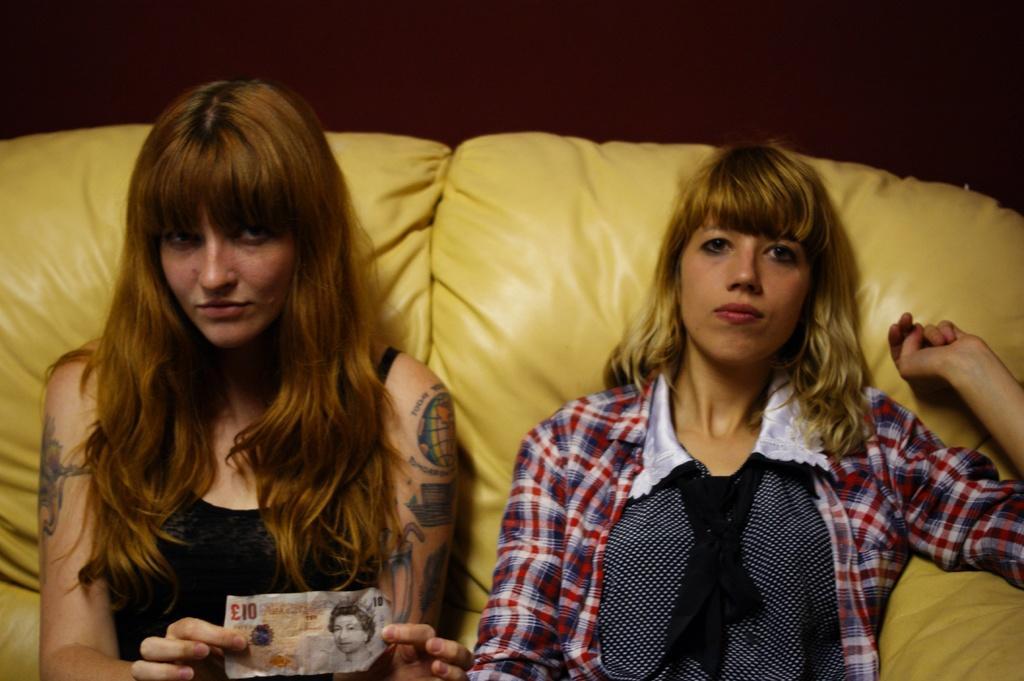Could you give a brief overview of what you see in this image? In this picture we can see women sitting on a sofa which is yellow in color. On the left side we can see a woman is holding a currency note with her hands. 